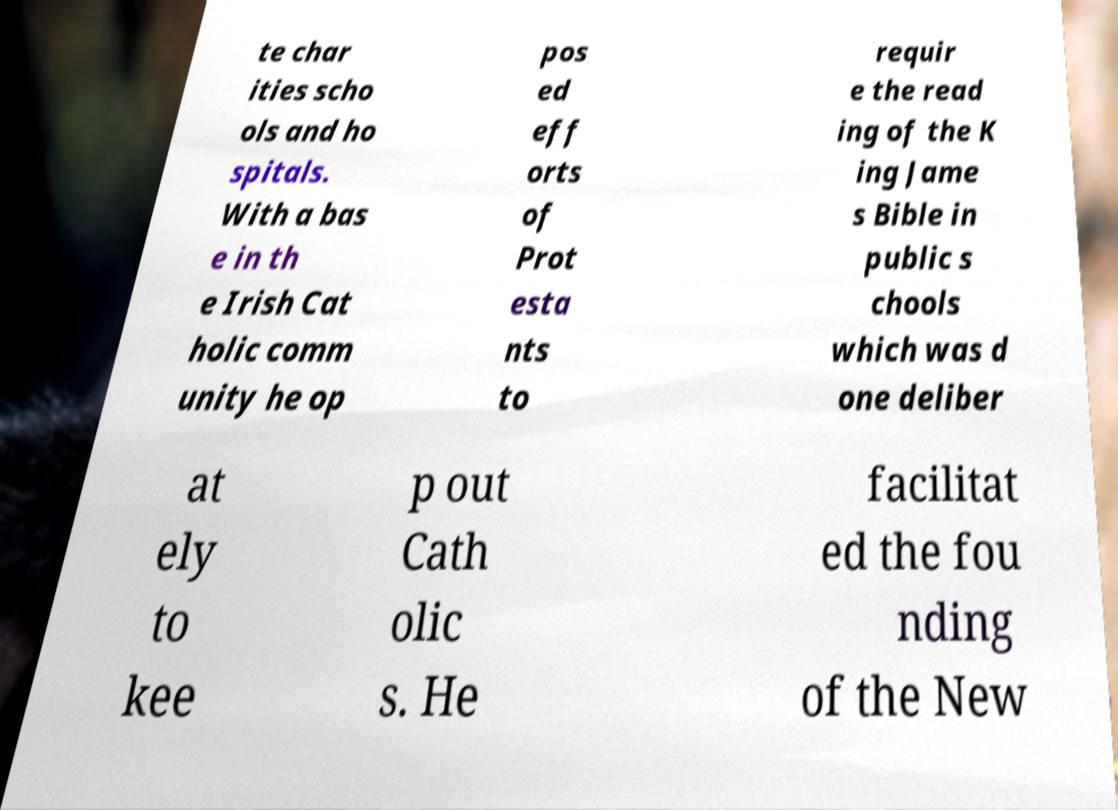Can you accurately transcribe the text from the provided image for me? te char ities scho ols and ho spitals. With a bas e in th e Irish Cat holic comm unity he op pos ed eff orts of Prot esta nts to requir e the read ing of the K ing Jame s Bible in public s chools which was d one deliber at ely to kee p out Cath olic s. He facilitat ed the fou nding of the New 